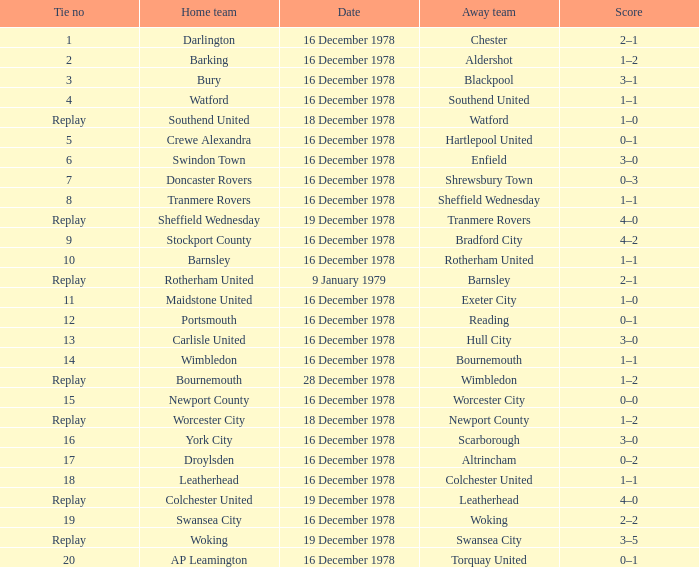Waht was the away team when the home team is colchester united? Leatherhead. 